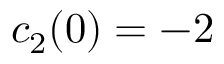Convert formula to latex. <formula><loc_0><loc_0><loc_500><loc_500>c _ { 2 } ( 0 ) = - 2</formula> 